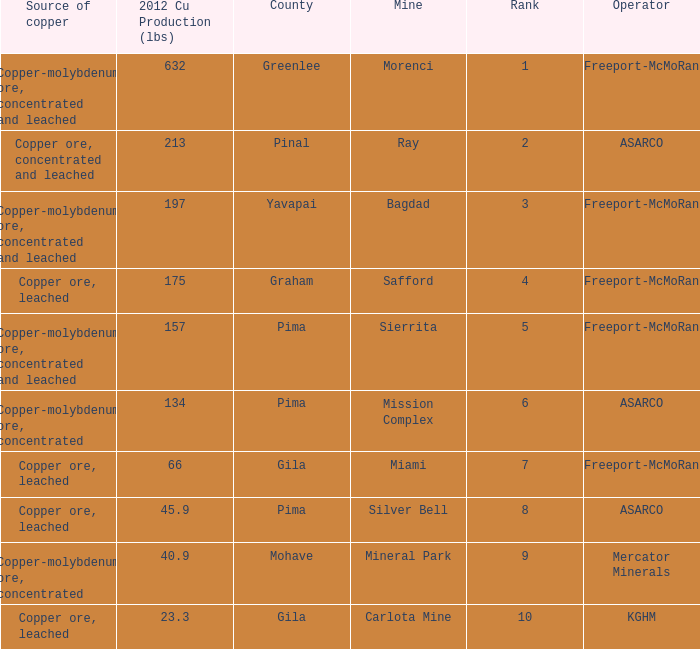What's the name of the operator who has the mission complex mine and has a 2012 Cu Production (lbs) larger than 23.3? ASARCO. 